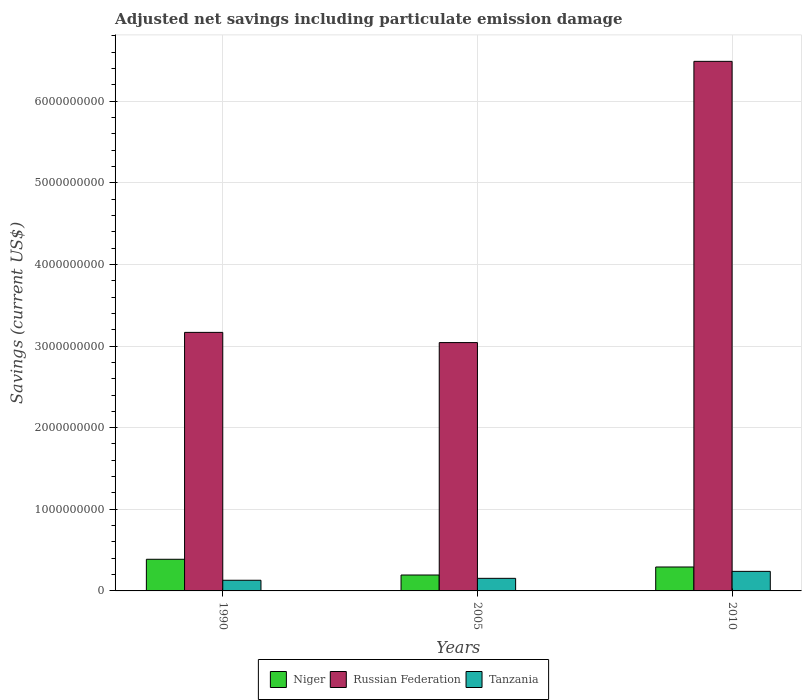How many different coloured bars are there?
Keep it short and to the point. 3. How many groups of bars are there?
Keep it short and to the point. 3. Are the number of bars per tick equal to the number of legend labels?
Provide a succinct answer. Yes. What is the label of the 1st group of bars from the left?
Your answer should be very brief. 1990. In how many cases, is the number of bars for a given year not equal to the number of legend labels?
Ensure brevity in your answer.  0. What is the net savings in Niger in 2010?
Offer a terse response. 2.93e+08. Across all years, what is the maximum net savings in Russian Federation?
Make the answer very short. 6.49e+09. Across all years, what is the minimum net savings in Niger?
Provide a short and direct response. 1.95e+08. In which year was the net savings in Tanzania maximum?
Make the answer very short. 2010. What is the total net savings in Russian Federation in the graph?
Keep it short and to the point. 1.27e+1. What is the difference between the net savings in Tanzania in 1990 and that in 2010?
Keep it short and to the point. -1.09e+08. What is the difference between the net savings in Russian Federation in 2010 and the net savings in Tanzania in 2005?
Provide a short and direct response. 6.33e+09. What is the average net savings in Tanzania per year?
Give a very brief answer. 1.75e+08. In the year 2010, what is the difference between the net savings in Russian Federation and net savings in Tanzania?
Your response must be concise. 6.25e+09. What is the ratio of the net savings in Niger in 1990 to that in 2010?
Provide a succinct answer. 1.32. Is the net savings in Niger in 1990 less than that in 2010?
Keep it short and to the point. No. Is the difference between the net savings in Russian Federation in 2005 and 2010 greater than the difference between the net savings in Tanzania in 2005 and 2010?
Your answer should be very brief. No. What is the difference between the highest and the second highest net savings in Russian Federation?
Provide a succinct answer. 3.32e+09. What is the difference between the highest and the lowest net savings in Tanzania?
Give a very brief answer. 1.09e+08. In how many years, is the net savings in Niger greater than the average net savings in Niger taken over all years?
Your answer should be compact. 2. Is the sum of the net savings in Niger in 1990 and 2010 greater than the maximum net savings in Tanzania across all years?
Keep it short and to the point. Yes. What does the 2nd bar from the left in 2010 represents?
Your response must be concise. Russian Federation. What does the 3rd bar from the right in 2010 represents?
Your answer should be very brief. Niger. How many bars are there?
Give a very brief answer. 9. Are all the bars in the graph horizontal?
Keep it short and to the point. No. What is the difference between two consecutive major ticks on the Y-axis?
Provide a short and direct response. 1.00e+09. Does the graph contain any zero values?
Your answer should be very brief. No. Does the graph contain grids?
Offer a very short reply. Yes. What is the title of the graph?
Keep it short and to the point. Adjusted net savings including particulate emission damage. Does "Iran" appear as one of the legend labels in the graph?
Your answer should be compact. No. What is the label or title of the X-axis?
Your response must be concise. Years. What is the label or title of the Y-axis?
Your response must be concise. Savings (current US$). What is the Savings (current US$) of Niger in 1990?
Keep it short and to the point. 3.88e+08. What is the Savings (current US$) in Russian Federation in 1990?
Give a very brief answer. 3.17e+09. What is the Savings (current US$) in Tanzania in 1990?
Offer a very short reply. 1.31e+08. What is the Savings (current US$) in Niger in 2005?
Provide a short and direct response. 1.95e+08. What is the Savings (current US$) in Russian Federation in 2005?
Your answer should be very brief. 3.04e+09. What is the Savings (current US$) of Tanzania in 2005?
Your answer should be compact. 1.54e+08. What is the Savings (current US$) in Niger in 2010?
Your answer should be compact. 2.93e+08. What is the Savings (current US$) of Russian Federation in 2010?
Provide a succinct answer. 6.49e+09. What is the Savings (current US$) of Tanzania in 2010?
Offer a very short reply. 2.39e+08. Across all years, what is the maximum Savings (current US$) of Niger?
Give a very brief answer. 3.88e+08. Across all years, what is the maximum Savings (current US$) in Russian Federation?
Keep it short and to the point. 6.49e+09. Across all years, what is the maximum Savings (current US$) of Tanzania?
Make the answer very short. 2.39e+08. Across all years, what is the minimum Savings (current US$) of Niger?
Give a very brief answer. 1.95e+08. Across all years, what is the minimum Savings (current US$) in Russian Federation?
Your answer should be compact. 3.04e+09. Across all years, what is the minimum Savings (current US$) of Tanzania?
Keep it short and to the point. 1.31e+08. What is the total Savings (current US$) in Niger in the graph?
Offer a very short reply. 8.76e+08. What is the total Savings (current US$) in Russian Federation in the graph?
Keep it short and to the point. 1.27e+1. What is the total Savings (current US$) in Tanzania in the graph?
Your response must be concise. 5.24e+08. What is the difference between the Savings (current US$) of Niger in 1990 and that in 2005?
Make the answer very short. 1.93e+08. What is the difference between the Savings (current US$) of Russian Federation in 1990 and that in 2005?
Offer a very short reply. 1.25e+08. What is the difference between the Savings (current US$) in Tanzania in 1990 and that in 2005?
Keep it short and to the point. -2.35e+07. What is the difference between the Savings (current US$) in Niger in 1990 and that in 2010?
Ensure brevity in your answer.  9.45e+07. What is the difference between the Savings (current US$) in Russian Federation in 1990 and that in 2010?
Your answer should be very brief. -3.32e+09. What is the difference between the Savings (current US$) of Tanzania in 1990 and that in 2010?
Ensure brevity in your answer.  -1.09e+08. What is the difference between the Savings (current US$) in Niger in 2005 and that in 2010?
Give a very brief answer. -9.82e+07. What is the difference between the Savings (current US$) of Russian Federation in 2005 and that in 2010?
Give a very brief answer. -3.45e+09. What is the difference between the Savings (current US$) in Tanzania in 2005 and that in 2010?
Provide a succinct answer. -8.53e+07. What is the difference between the Savings (current US$) of Niger in 1990 and the Savings (current US$) of Russian Federation in 2005?
Provide a succinct answer. -2.65e+09. What is the difference between the Savings (current US$) in Niger in 1990 and the Savings (current US$) in Tanzania in 2005?
Ensure brevity in your answer.  2.33e+08. What is the difference between the Savings (current US$) in Russian Federation in 1990 and the Savings (current US$) in Tanzania in 2005?
Give a very brief answer. 3.01e+09. What is the difference between the Savings (current US$) of Niger in 1990 and the Savings (current US$) of Russian Federation in 2010?
Offer a terse response. -6.10e+09. What is the difference between the Savings (current US$) in Niger in 1990 and the Savings (current US$) in Tanzania in 2010?
Ensure brevity in your answer.  1.48e+08. What is the difference between the Savings (current US$) of Russian Federation in 1990 and the Savings (current US$) of Tanzania in 2010?
Ensure brevity in your answer.  2.93e+09. What is the difference between the Savings (current US$) of Niger in 2005 and the Savings (current US$) of Russian Federation in 2010?
Keep it short and to the point. -6.29e+09. What is the difference between the Savings (current US$) of Niger in 2005 and the Savings (current US$) of Tanzania in 2010?
Offer a terse response. -4.45e+07. What is the difference between the Savings (current US$) in Russian Federation in 2005 and the Savings (current US$) in Tanzania in 2010?
Make the answer very short. 2.80e+09. What is the average Savings (current US$) of Niger per year?
Make the answer very short. 2.92e+08. What is the average Savings (current US$) in Russian Federation per year?
Give a very brief answer. 4.23e+09. What is the average Savings (current US$) in Tanzania per year?
Offer a terse response. 1.75e+08. In the year 1990, what is the difference between the Savings (current US$) in Niger and Savings (current US$) in Russian Federation?
Your response must be concise. -2.78e+09. In the year 1990, what is the difference between the Savings (current US$) of Niger and Savings (current US$) of Tanzania?
Your answer should be very brief. 2.57e+08. In the year 1990, what is the difference between the Savings (current US$) of Russian Federation and Savings (current US$) of Tanzania?
Provide a succinct answer. 3.04e+09. In the year 2005, what is the difference between the Savings (current US$) of Niger and Savings (current US$) of Russian Federation?
Provide a short and direct response. -2.85e+09. In the year 2005, what is the difference between the Savings (current US$) of Niger and Savings (current US$) of Tanzania?
Keep it short and to the point. 4.08e+07. In the year 2005, what is the difference between the Savings (current US$) of Russian Federation and Savings (current US$) of Tanzania?
Keep it short and to the point. 2.89e+09. In the year 2010, what is the difference between the Savings (current US$) of Niger and Savings (current US$) of Russian Federation?
Your answer should be compact. -6.19e+09. In the year 2010, what is the difference between the Savings (current US$) of Niger and Savings (current US$) of Tanzania?
Give a very brief answer. 5.37e+07. In the year 2010, what is the difference between the Savings (current US$) in Russian Federation and Savings (current US$) in Tanzania?
Provide a short and direct response. 6.25e+09. What is the ratio of the Savings (current US$) of Niger in 1990 to that in 2005?
Give a very brief answer. 1.99. What is the ratio of the Savings (current US$) of Russian Federation in 1990 to that in 2005?
Your response must be concise. 1.04. What is the ratio of the Savings (current US$) in Tanzania in 1990 to that in 2005?
Offer a terse response. 0.85. What is the ratio of the Savings (current US$) in Niger in 1990 to that in 2010?
Offer a terse response. 1.32. What is the ratio of the Savings (current US$) of Russian Federation in 1990 to that in 2010?
Your response must be concise. 0.49. What is the ratio of the Savings (current US$) in Tanzania in 1990 to that in 2010?
Offer a very short reply. 0.55. What is the ratio of the Savings (current US$) of Niger in 2005 to that in 2010?
Ensure brevity in your answer.  0.67. What is the ratio of the Savings (current US$) in Russian Federation in 2005 to that in 2010?
Ensure brevity in your answer.  0.47. What is the ratio of the Savings (current US$) of Tanzania in 2005 to that in 2010?
Keep it short and to the point. 0.64. What is the difference between the highest and the second highest Savings (current US$) of Niger?
Provide a short and direct response. 9.45e+07. What is the difference between the highest and the second highest Savings (current US$) of Russian Federation?
Keep it short and to the point. 3.32e+09. What is the difference between the highest and the second highest Savings (current US$) of Tanzania?
Make the answer very short. 8.53e+07. What is the difference between the highest and the lowest Savings (current US$) in Niger?
Your answer should be compact. 1.93e+08. What is the difference between the highest and the lowest Savings (current US$) of Russian Federation?
Your answer should be very brief. 3.45e+09. What is the difference between the highest and the lowest Savings (current US$) in Tanzania?
Your response must be concise. 1.09e+08. 